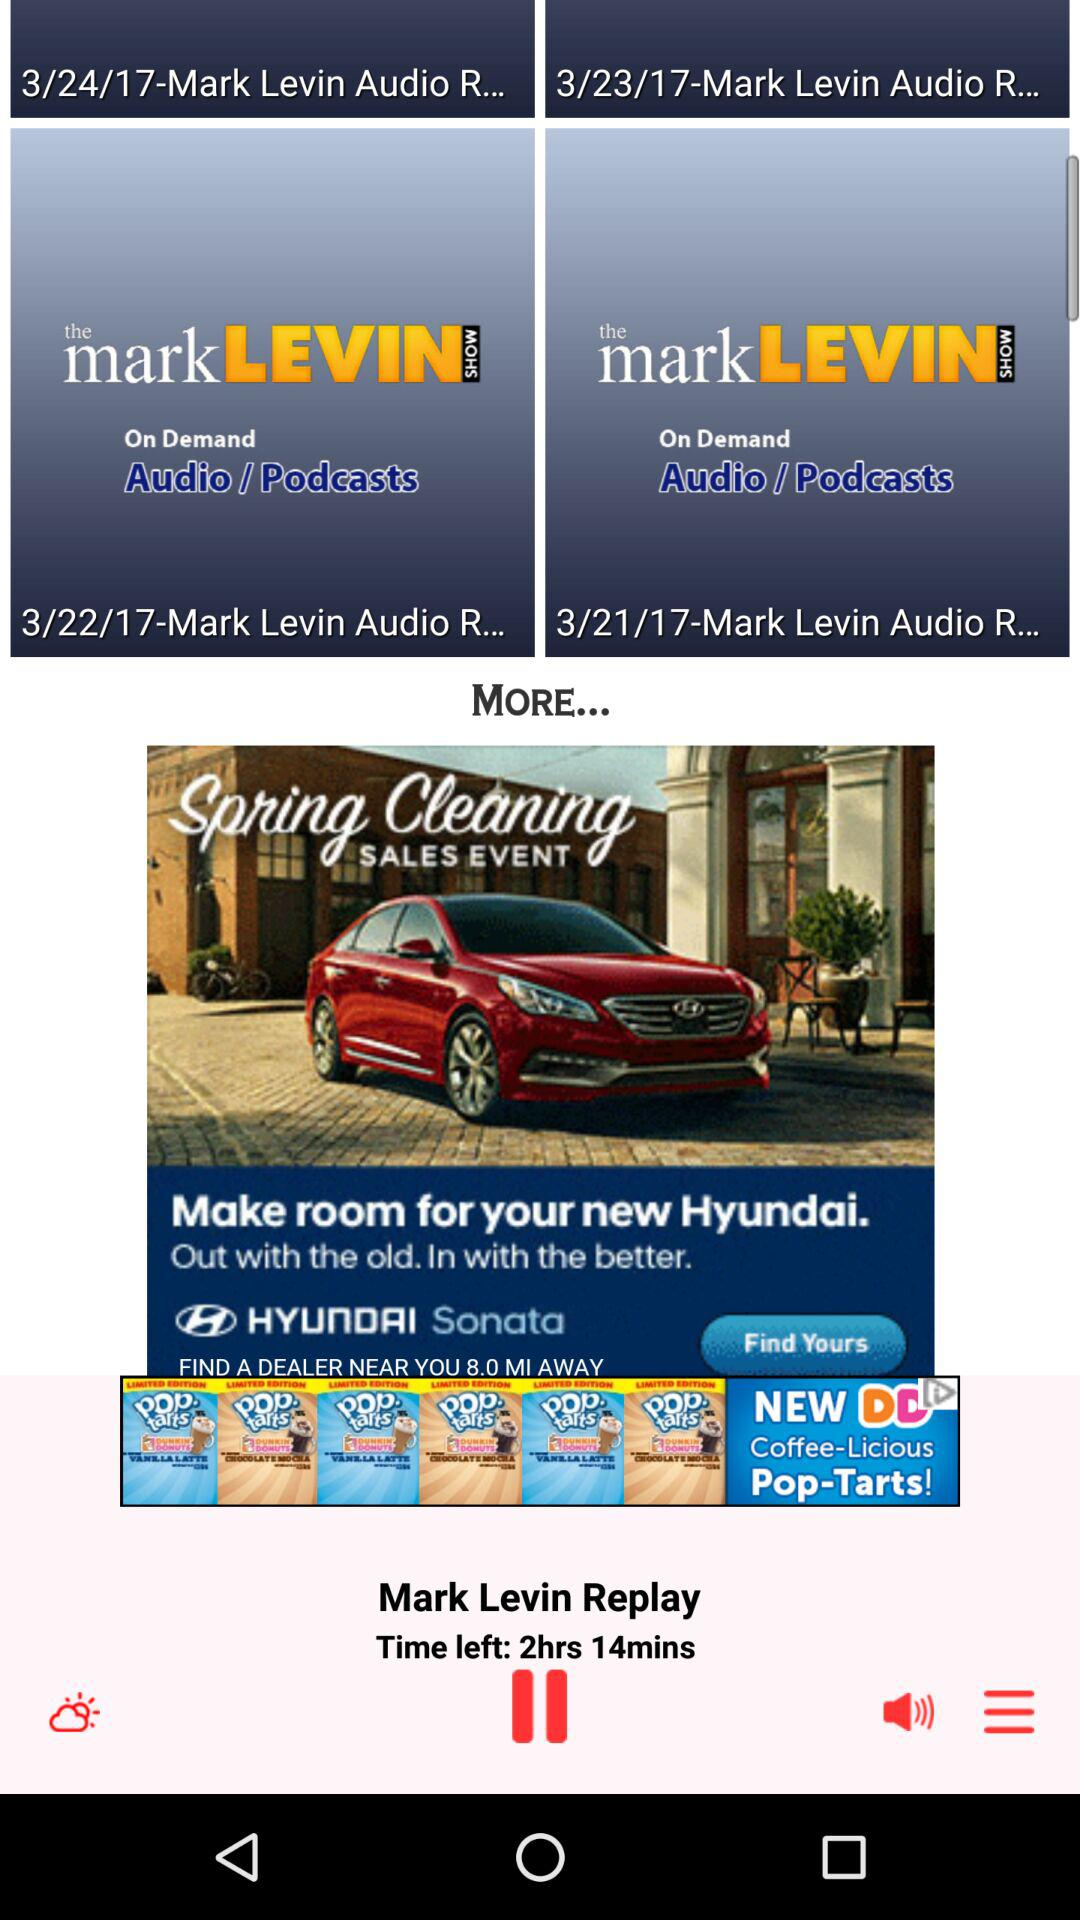What are the dates of the audio podcasts? The dates are March 24, 2017, March 23, 2017, March 22, 2017 and March 21, 2017. 